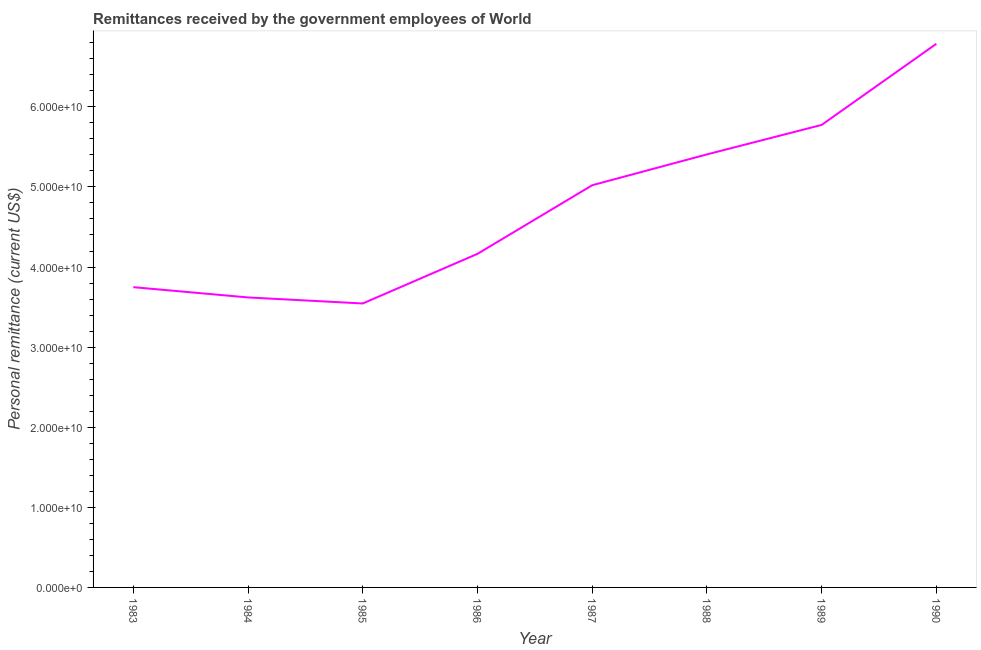What is the personal remittances in 1989?
Your answer should be compact. 5.77e+1. Across all years, what is the maximum personal remittances?
Offer a very short reply. 6.79e+1. Across all years, what is the minimum personal remittances?
Keep it short and to the point. 3.55e+1. In which year was the personal remittances minimum?
Your answer should be very brief. 1985. What is the sum of the personal remittances?
Your response must be concise. 3.81e+11. What is the difference between the personal remittances in 1983 and 1990?
Offer a terse response. -3.04e+1. What is the average personal remittances per year?
Your response must be concise. 4.76e+1. What is the median personal remittances?
Your response must be concise. 4.59e+1. Do a majority of the years between 1986 and 1988 (inclusive) have personal remittances greater than 20000000000 US$?
Give a very brief answer. Yes. What is the ratio of the personal remittances in 1983 to that in 1984?
Provide a short and direct response. 1.04. Is the difference between the personal remittances in 1989 and 1990 greater than the difference between any two years?
Ensure brevity in your answer.  No. What is the difference between the highest and the second highest personal remittances?
Provide a short and direct response. 1.01e+1. Is the sum of the personal remittances in 1986 and 1987 greater than the maximum personal remittances across all years?
Make the answer very short. Yes. What is the difference between the highest and the lowest personal remittances?
Offer a very short reply. 3.24e+1. In how many years, is the personal remittances greater than the average personal remittances taken over all years?
Your answer should be compact. 4. How many lines are there?
Keep it short and to the point. 1. How many years are there in the graph?
Provide a short and direct response. 8. What is the difference between two consecutive major ticks on the Y-axis?
Offer a very short reply. 1.00e+1. Are the values on the major ticks of Y-axis written in scientific E-notation?
Keep it short and to the point. Yes. What is the title of the graph?
Your answer should be compact. Remittances received by the government employees of World. What is the label or title of the X-axis?
Make the answer very short. Year. What is the label or title of the Y-axis?
Ensure brevity in your answer.  Personal remittance (current US$). What is the Personal remittance (current US$) in 1983?
Provide a short and direct response. 3.75e+1. What is the Personal remittance (current US$) of 1984?
Keep it short and to the point. 3.62e+1. What is the Personal remittance (current US$) in 1985?
Offer a very short reply. 3.55e+1. What is the Personal remittance (current US$) of 1986?
Offer a very short reply. 4.16e+1. What is the Personal remittance (current US$) in 1987?
Provide a short and direct response. 5.02e+1. What is the Personal remittance (current US$) in 1988?
Provide a short and direct response. 5.41e+1. What is the Personal remittance (current US$) in 1989?
Your response must be concise. 5.77e+1. What is the Personal remittance (current US$) in 1990?
Provide a succinct answer. 6.79e+1. What is the difference between the Personal remittance (current US$) in 1983 and 1984?
Provide a succinct answer. 1.28e+09. What is the difference between the Personal remittance (current US$) in 1983 and 1985?
Ensure brevity in your answer.  2.03e+09. What is the difference between the Personal remittance (current US$) in 1983 and 1986?
Keep it short and to the point. -4.16e+09. What is the difference between the Personal remittance (current US$) in 1983 and 1987?
Your response must be concise. -1.27e+1. What is the difference between the Personal remittance (current US$) in 1983 and 1988?
Your answer should be compact. -1.66e+1. What is the difference between the Personal remittance (current US$) in 1983 and 1989?
Give a very brief answer. -2.03e+1. What is the difference between the Personal remittance (current US$) in 1983 and 1990?
Keep it short and to the point. -3.04e+1. What is the difference between the Personal remittance (current US$) in 1984 and 1985?
Keep it short and to the point. 7.52e+08. What is the difference between the Personal remittance (current US$) in 1984 and 1986?
Ensure brevity in your answer.  -5.44e+09. What is the difference between the Personal remittance (current US$) in 1984 and 1987?
Ensure brevity in your answer.  -1.40e+1. What is the difference between the Personal remittance (current US$) in 1984 and 1988?
Keep it short and to the point. -1.79e+1. What is the difference between the Personal remittance (current US$) in 1984 and 1989?
Your response must be concise. -2.15e+1. What is the difference between the Personal remittance (current US$) in 1984 and 1990?
Provide a short and direct response. -3.17e+1. What is the difference between the Personal remittance (current US$) in 1985 and 1986?
Offer a terse response. -6.19e+09. What is the difference between the Personal remittance (current US$) in 1985 and 1987?
Provide a succinct answer. -1.48e+1. What is the difference between the Personal remittance (current US$) in 1985 and 1988?
Your response must be concise. -1.86e+1. What is the difference between the Personal remittance (current US$) in 1985 and 1989?
Ensure brevity in your answer.  -2.23e+1. What is the difference between the Personal remittance (current US$) in 1985 and 1990?
Offer a very short reply. -3.24e+1. What is the difference between the Personal remittance (current US$) in 1986 and 1987?
Give a very brief answer. -8.57e+09. What is the difference between the Personal remittance (current US$) in 1986 and 1988?
Offer a very short reply. -1.24e+1. What is the difference between the Personal remittance (current US$) in 1986 and 1989?
Provide a short and direct response. -1.61e+1. What is the difference between the Personal remittance (current US$) in 1986 and 1990?
Offer a very short reply. -2.62e+1. What is the difference between the Personal remittance (current US$) in 1987 and 1988?
Your response must be concise. -3.85e+09. What is the difference between the Personal remittance (current US$) in 1987 and 1989?
Provide a short and direct response. -7.53e+09. What is the difference between the Personal remittance (current US$) in 1987 and 1990?
Give a very brief answer. -1.77e+1. What is the difference between the Personal remittance (current US$) in 1988 and 1989?
Keep it short and to the point. -3.68e+09. What is the difference between the Personal remittance (current US$) in 1988 and 1990?
Your answer should be compact. -1.38e+1. What is the difference between the Personal remittance (current US$) in 1989 and 1990?
Provide a short and direct response. -1.01e+1. What is the ratio of the Personal remittance (current US$) in 1983 to that in 1984?
Your answer should be compact. 1.03. What is the ratio of the Personal remittance (current US$) in 1983 to that in 1985?
Offer a terse response. 1.06. What is the ratio of the Personal remittance (current US$) in 1983 to that in 1986?
Offer a terse response. 0.9. What is the ratio of the Personal remittance (current US$) in 1983 to that in 1987?
Offer a very short reply. 0.75. What is the ratio of the Personal remittance (current US$) in 1983 to that in 1988?
Ensure brevity in your answer.  0.69. What is the ratio of the Personal remittance (current US$) in 1983 to that in 1989?
Offer a very short reply. 0.65. What is the ratio of the Personal remittance (current US$) in 1983 to that in 1990?
Offer a terse response. 0.55. What is the ratio of the Personal remittance (current US$) in 1984 to that in 1986?
Provide a short and direct response. 0.87. What is the ratio of the Personal remittance (current US$) in 1984 to that in 1987?
Your answer should be compact. 0.72. What is the ratio of the Personal remittance (current US$) in 1984 to that in 1988?
Ensure brevity in your answer.  0.67. What is the ratio of the Personal remittance (current US$) in 1984 to that in 1989?
Offer a very short reply. 0.63. What is the ratio of the Personal remittance (current US$) in 1984 to that in 1990?
Make the answer very short. 0.53. What is the ratio of the Personal remittance (current US$) in 1985 to that in 1986?
Make the answer very short. 0.85. What is the ratio of the Personal remittance (current US$) in 1985 to that in 1987?
Make the answer very short. 0.71. What is the ratio of the Personal remittance (current US$) in 1985 to that in 1988?
Your answer should be very brief. 0.66. What is the ratio of the Personal remittance (current US$) in 1985 to that in 1989?
Offer a very short reply. 0.61. What is the ratio of the Personal remittance (current US$) in 1985 to that in 1990?
Your answer should be compact. 0.52. What is the ratio of the Personal remittance (current US$) in 1986 to that in 1987?
Provide a succinct answer. 0.83. What is the ratio of the Personal remittance (current US$) in 1986 to that in 1988?
Your answer should be very brief. 0.77. What is the ratio of the Personal remittance (current US$) in 1986 to that in 1989?
Make the answer very short. 0.72. What is the ratio of the Personal remittance (current US$) in 1986 to that in 1990?
Provide a short and direct response. 0.61. What is the ratio of the Personal remittance (current US$) in 1987 to that in 1988?
Your response must be concise. 0.93. What is the ratio of the Personal remittance (current US$) in 1987 to that in 1989?
Provide a succinct answer. 0.87. What is the ratio of the Personal remittance (current US$) in 1987 to that in 1990?
Give a very brief answer. 0.74. What is the ratio of the Personal remittance (current US$) in 1988 to that in 1989?
Provide a succinct answer. 0.94. What is the ratio of the Personal remittance (current US$) in 1988 to that in 1990?
Your answer should be very brief. 0.8. What is the ratio of the Personal remittance (current US$) in 1989 to that in 1990?
Offer a very short reply. 0.85. 